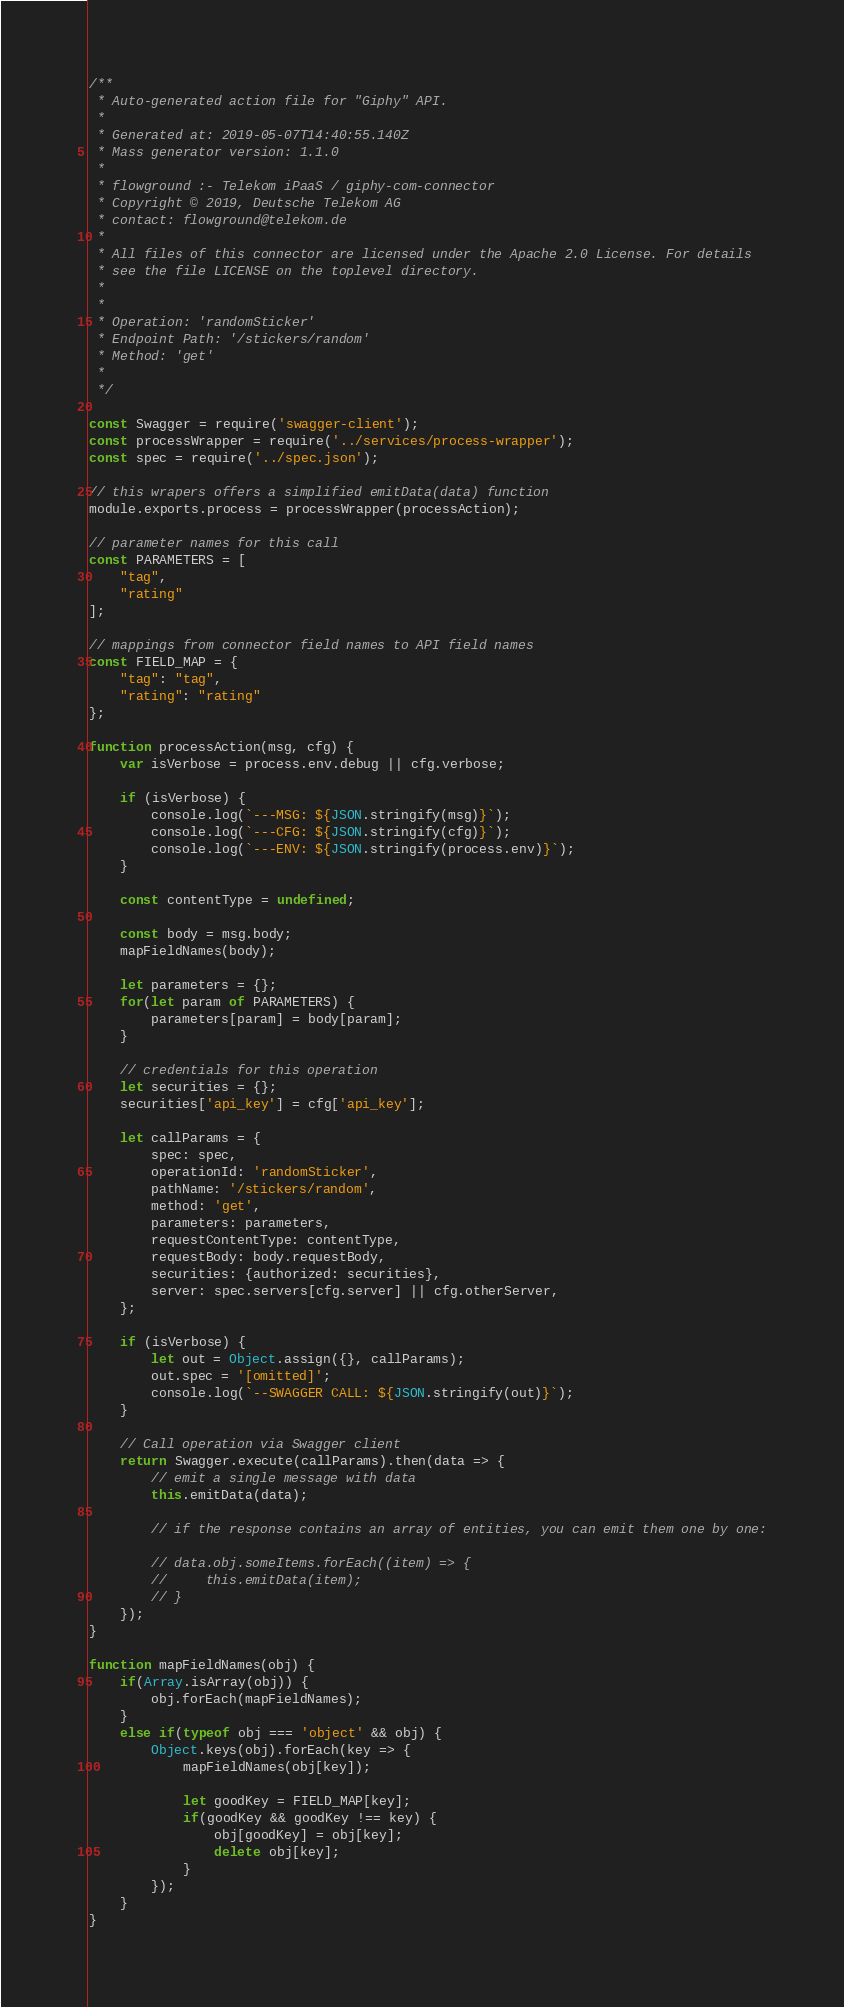Convert code to text. <code><loc_0><loc_0><loc_500><loc_500><_JavaScript_>/**
 * Auto-generated action file for "Giphy" API.
 *
 * Generated at: 2019-05-07T14:40:55.140Z
 * Mass generator version: 1.1.0
 *
 * flowground :- Telekom iPaaS / giphy-com-connector
 * Copyright © 2019, Deutsche Telekom AG
 * contact: flowground@telekom.de
 *
 * All files of this connector are licensed under the Apache 2.0 License. For details
 * see the file LICENSE on the toplevel directory.
 *
 *
 * Operation: 'randomSticker'
 * Endpoint Path: '/stickers/random'
 * Method: 'get'
 *
 */

const Swagger = require('swagger-client');
const processWrapper = require('../services/process-wrapper');
const spec = require('../spec.json');

// this wrapers offers a simplified emitData(data) function
module.exports.process = processWrapper(processAction);

// parameter names for this call
const PARAMETERS = [
    "tag",
    "rating"
];

// mappings from connector field names to API field names
const FIELD_MAP = {
    "tag": "tag",
    "rating": "rating"
};

function processAction(msg, cfg) {
    var isVerbose = process.env.debug || cfg.verbose;

    if (isVerbose) {
        console.log(`---MSG: ${JSON.stringify(msg)}`);
        console.log(`---CFG: ${JSON.stringify(cfg)}`);
        console.log(`---ENV: ${JSON.stringify(process.env)}`);
    }

    const contentType = undefined;

    const body = msg.body;
    mapFieldNames(body);

    let parameters = {};
    for(let param of PARAMETERS) {
        parameters[param] = body[param];
    }

    // credentials for this operation
    let securities = {};
    securities['api_key'] = cfg['api_key'];

    let callParams = {
        spec: spec,
        operationId: 'randomSticker',
        pathName: '/stickers/random',
        method: 'get',
        parameters: parameters,
        requestContentType: contentType,
        requestBody: body.requestBody,
        securities: {authorized: securities},
        server: spec.servers[cfg.server] || cfg.otherServer,
    };

    if (isVerbose) {
        let out = Object.assign({}, callParams);
        out.spec = '[omitted]';
        console.log(`--SWAGGER CALL: ${JSON.stringify(out)}`);
    }

    // Call operation via Swagger client
    return Swagger.execute(callParams).then(data => {
        // emit a single message with data
        this.emitData(data);

        // if the response contains an array of entities, you can emit them one by one:

        // data.obj.someItems.forEach((item) => {
        //     this.emitData(item);
        // }
    });
}

function mapFieldNames(obj) {
    if(Array.isArray(obj)) {
        obj.forEach(mapFieldNames);
    }
    else if(typeof obj === 'object' && obj) {
        Object.keys(obj).forEach(key => {
            mapFieldNames(obj[key]);

            let goodKey = FIELD_MAP[key];
            if(goodKey && goodKey !== key) {
                obj[goodKey] = obj[key];
                delete obj[key];
            }
        });
    }
}</code> 